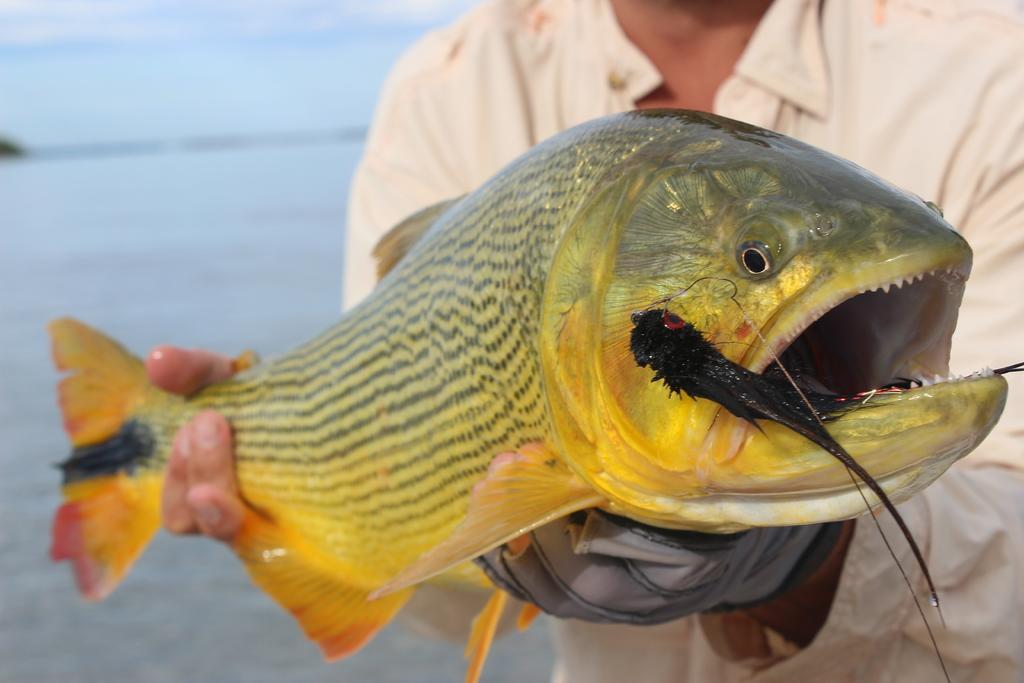Can you describe this image briefly? In this image we can see a person holding a fish. In the background there is water and we can see the sky. 